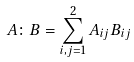<formula> <loc_0><loc_0><loc_500><loc_500>A \colon B = \sum _ { i , j = 1 } ^ { 2 } A _ { i j } B _ { i j }</formula> 